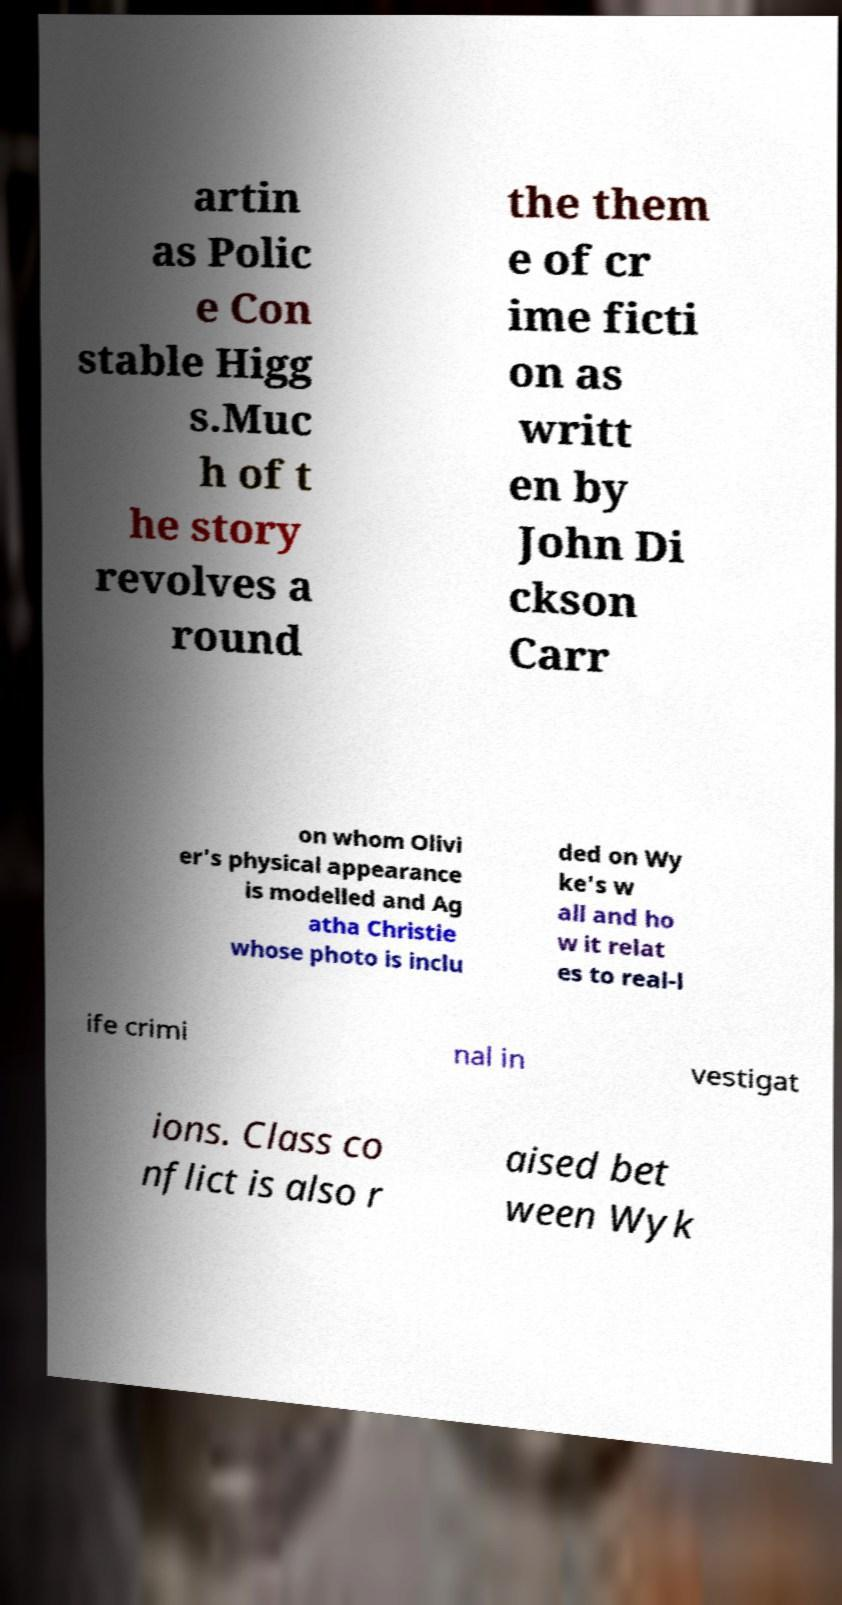There's text embedded in this image that I need extracted. Can you transcribe it verbatim? artin as Polic e Con stable Higg s.Muc h of t he story revolves a round the them e of cr ime ficti on as writt en by John Di ckson Carr on whom Olivi er's physical appearance is modelled and Ag atha Christie whose photo is inclu ded on Wy ke's w all and ho w it relat es to real-l ife crimi nal in vestigat ions. Class co nflict is also r aised bet ween Wyk 